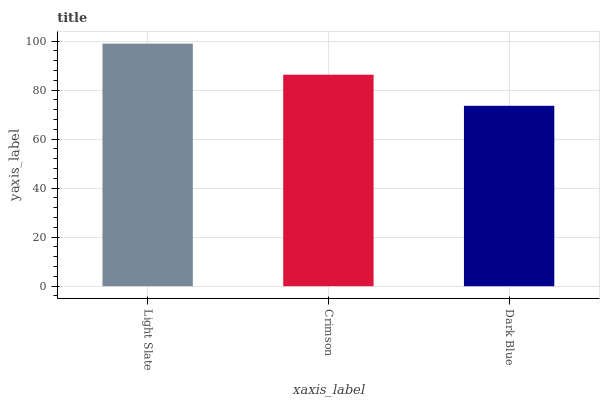Is Dark Blue the minimum?
Answer yes or no. Yes. Is Light Slate the maximum?
Answer yes or no. Yes. Is Crimson the minimum?
Answer yes or no. No. Is Crimson the maximum?
Answer yes or no. No. Is Light Slate greater than Crimson?
Answer yes or no. Yes. Is Crimson less than Light Slate?
Answer yes or no. Yes. Is Crimson greater than Light Slate?
Answer yes or no. No. Is Light Slate less than Crimson?
Answer yes or no. No. Is Crimson the high median?
Answer yes or no. Yes. Is Crimson the low median?
Answer yes or no. Yes. Is Dark Blue the high median?
Answer yes or no. No. Is Dark Blue the low median?
Answer yes or no. No. 